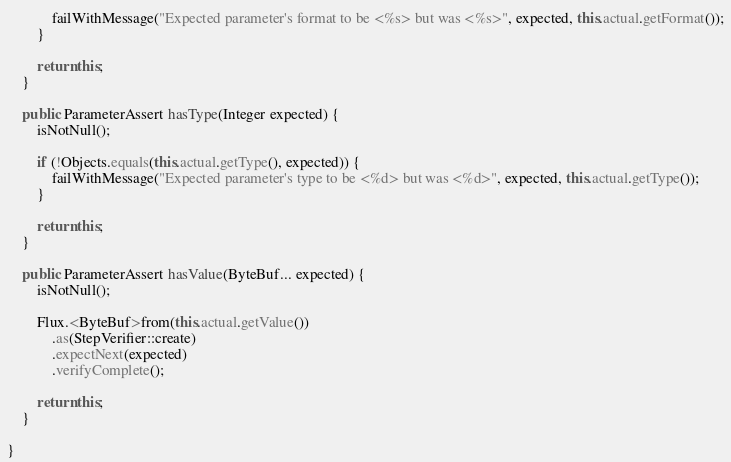Convert code to text. <code><loc_0><loc_0><loc_500><loc_500><_Java_>            failWithMessage("Expected parameter's format to be <%s> but was <%s>", expected, this.actual.getFormat());
        }

        return this;
    }

    public ParameterAssert hasType(Integer expected) {
        isNotNull();

        if (!Objects.equals(this.actual.getType(), expected)) {
            failWithMessage("Expected parameter's type to be <%d> but was <%d>", expected, this.actual.getType());
        }

        return this;
    }

    public ParameterAssert hasValue(ByteBuf... expected) {
        isNotNull();

        Flux.<ByteBuf>from(this.actual.getValue())
            .as(StepVerifier::create)
            .expectNext(expected)
            .verifyComplete();

        return this;
    }

}
</code> 